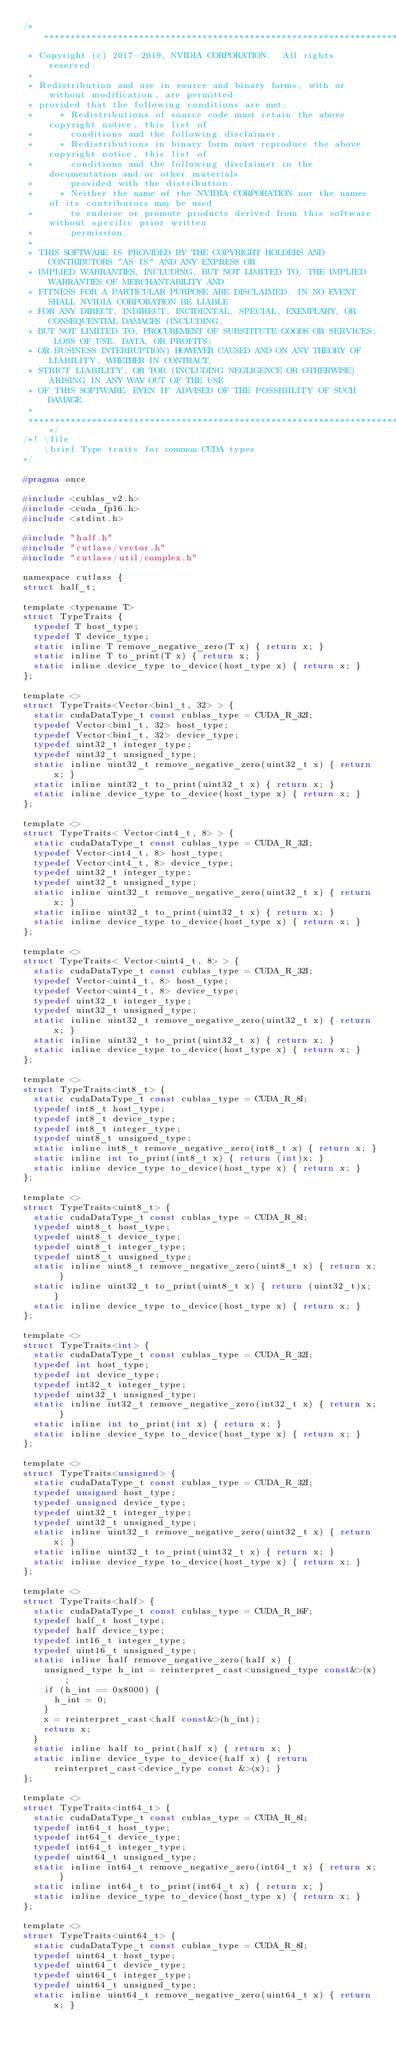<code> <loc_0><loc_0><loc_500><loc_500><_C_>/***************************************************************************************************
 * Copyright (c) 2017-2019, NVIDIA CORPORATION.  All rights reserved.
 *
 * Redistribution and use in source and binary forms, with or without modification, are permitted
 * provided that the following conditions are met:
 *     * Redistributions of source code must retain the above copyright notice, this list of
 *       conditions and the following disclaimer.
 *     * Redistributions in binary form must reproduce the above copyright notice, this list of
 *       conditions and the following disclaimer in the documentation and/or other materials
 *       provided with the distribution.
 *     * Neither the name of the NVIDIA CORPORATION nor the names of its contributors may be used
 *       to endorse or promote products derived from this software without specific prior written
 *       permission.
 *
 * THIS SOFTWARE IS PROVIDED BY THE COPYRIGHT HOLDERS AND CONTRIBUTORS "AS IS" AND ANY EXPRESS OR
 * IMPLIED WARRANTIES, INCLUDING, BUT NOT LIMITED TO, THE IMPLIED WARRANTIES OF MERCHANTABILITY AND
 * FITNESS FOR A PARTICULAR PURPOSE ARE DISCLAIMED. IN NO EVENT SHALL NVIDIA CORPORATION BE LIABLE
 * FOR ANY DIRECT, INDIRECT, INCIDENTAL, SPECIAL, EXEMPLARY, OR CONSEQUENTIAL DAMAGES (INCLUDING,
 * BUT NOT LIMITED TO, PROCUREMENT OF SUBSTITUTE GOODS OR SERVICES; LOSS OF USE, DATA, OR PROFITS;
 * OR BUSINESS INTERRUPTION) HOWEVER CAUSED AND ON ANY THEORY OF LIABILITY, WHETHER IN CONTRACT,
 * STRICT LIABILITY, OR TOR (INCLUDING NEGLIGENCE OR OTHERWISE) ARISING IN ANY WAY OUT OF THE USE
 * OF THIS SOFTWARE, EVEN IF ADVISED OF THE POSSIBILITY OF SUCH DAMAGE.
 *
 **************************************************************************************************/
/*! \file
    \brief Type traits for common CUDA types
*/

#pragma once

#include <cublas_v2.h>
#include <cuda_fp16.h>
#include <stdint.h>

#include "half.h"
#include "cutlass/vector.h"
#include "cutlass/util/complex.h"

namespace cutlass {
struct half_t;

template <typename T>
struct TypeTraits {
  typedef T host_type;
  typedef T device_type;
  static inline T remove_negative_zero(T x) { return x; }
  static inline T to_print(T x) { return x; }
  static inline device_type to_device(host_type x) { return x; }
};

template <>
struct TypeTraits<Vector<bin1_t, 32> > {
  static cudaDataType_t const cublas_type = CUDA_R_32I;
  typedef Vector<bin1_t, 32> host_type;
  typedef Vector<bin1_t, 32> device_type;
  typedef uint32_t integer_type;
  typedef uint32_t unsigned_type;
  static inline uint32_t remove_negative_zero(uint32_t x) { return x; }
  static inline uint32_t to_print(uint32_t x) { return x; }
  static inline device_type to_device(host_type x) { return x; }
};

template <>
struct TypeTraits< Vector<int4_t, 8> > {
  static cudaDataType_t const cublas_type = CUDA_R_32I;
  typedef Vector<int4_t, 8> host_type;
  typedef Vector<int4_t, 8> device_type;
  typedef uint32_t integer_type;
  typedef uint32_t unsigned_type;
  static inline uint32_t remove_negative_zero(uint32_t x) { return x; }
  static inline uint32_t to_print(uint32_t x) { return x; }
  static inline device_type to_device(host_type x) { return x; }
};

template <>
struct TypeTraits< Vector<uint4_t, 8> > {
  static cudaDataType_t const cublas_type = CUDA_R_32I;
  typedef Vector<uint4_t, 8> host_type;
  typedef Vector<uint4_t, 8> device_type;
  typedef uint32_t integer_type;
  typedef uint32_t unsigned_type;
  static inline uint32_t remove_negative_zero(uint32_t x) { return x; }
  static inline uint32_t to_print(uint32_t x) { return x; }
  static inline device_type to_device(host_type x) { return x; }
};

template <>
struct TypeTraits<int8_t> {
  static cudaDataType_t const cublas_type = CUDA_R_8I;
  typedef int8_t host_type;
  typedef int8_t device_type;
  typedef int8_t integer_type;
  typedef uint8_t unsigned_type;
  static inline int8_t remove_negative_zero(int8_t x) { return x; }
  static inline int to_print(int8_t x) { return (int)x; }
  static inline device_type to_device(host_type x) { return x; }
};

template <>
struct TypeTraits<uint8_t> {
  static cudaDataType_t const cublas_type = CUDA_R_8I;
  typedef uint8_t host_type;
  typedef uint8_t device_type;
  typedef uint8_t integer_type;
  typedef uint8_t unsigned_type;
  static inline uint8_t remove_negative_zero(uint8_t x) { return x; }
  static inline uint32_t to_print(uint8_t x) { return (uint32_t)x; }
  static inline device_type to_device(host_type x) { return x; }
};

template <>
struct TypeTraits<int> {
  static cudaDataType_t const cublas_type = CUDA_R_32I;
  typedef int host_type;
  typedef int device_type;
  typedef int32_t integer_type;
  typedef uint32_t unsigned_type;
  static inline int32_t remove_negative_zero(int32_t x) { return x; }
  static inline int to_print(int x) { return x; }
  static inline device_type to_device(host_type x) { return x; }
};

template <>
struct TypeTraits<unsigned> {
  static cudaDataType_t const cublas_type = CUDA_R_32I;
  typedef unsigned host_type;
  typedef unsigned device_type;
  typedef uint32_t integer_type;
  typedef uint32_t unsigned_type;
  static inline uint32_t remove_negative_zero(uint32_t x) { return x; }
  static inline uint32_t to_print(uint32_t x) { return x; }
  static inline device_type to_device(host_type x) { return x; }
};

template <>
struct TypeTraits<half> {
  static cudaDataType_t const cublas_type = CUDA_R_16F;
  typedef half_t host_type;
  typedef half device_type;
  typedef int16_t integer_type;
  typedef uint16_t unsigned_type;
  static inline half remove_negative_zero(half x) {
    unsigned_type h_int = reinterpret_cast<unsigned_type const&>(x);
    if (h_int == 0x8000) {
      h_int = 0;
    }
    x = reinterpret_cast<half const&>(h_int);
    return x;
  }
  static inline half to_print(half x) { return x; }
  static inline device_type to_device(half x) { return reinterpret_cast<device_type const &>(x); }
};

template <>
struct TypeTraits<int64_t> {
  static cudaDataType_t const cublas_type = CUDA_R_8I;
  typedef int64_t host_type;
  typedef int64_t device_type;
  typedef int64_t integer_type;
  typedef uint64_t unsigned_type;
  static inline int64_t remove_negative_zero(int64_t x) { return x; }
  static inline int64_t to_print(int64_t x) { return x; }
  static inline device_type to_device(host_type x) { return x; }
};

template <>
struct TypeTraits<uint64_t> {
  static cudaDataType_t const cublas_type = CUDA_R_8I;
  typedef uint64_t host_type;
  typedef uint64_t device_type;
  typedef uint64_t integer_type;
  typedef uint64_t unsigned_type;
  static inline uint64_t remove_negative_zero(uint64_t x) { return x; }</code> 